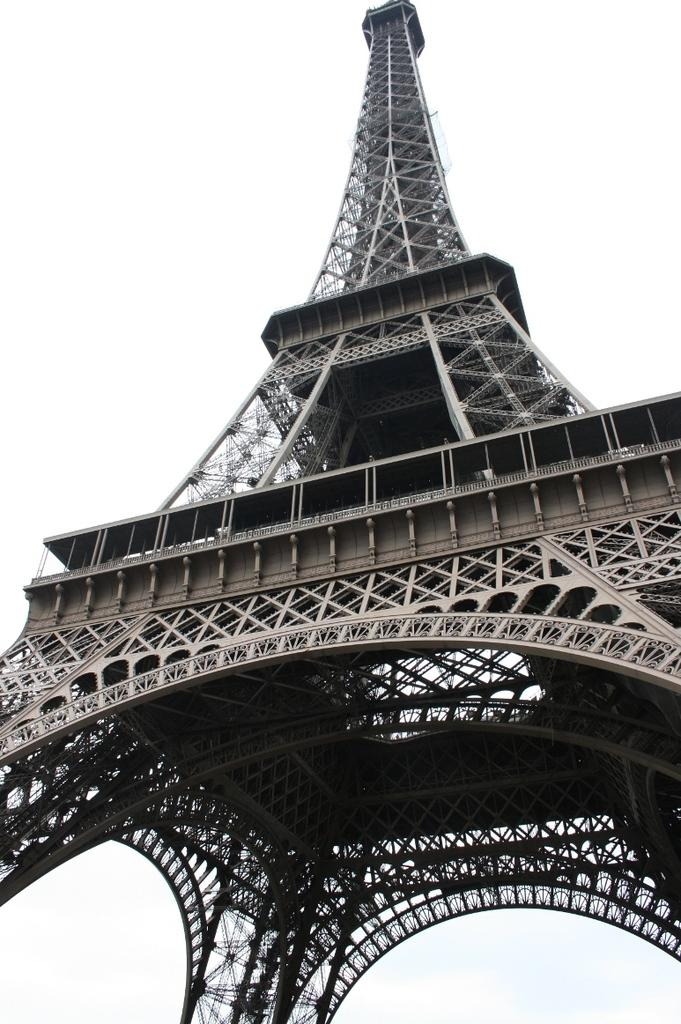What famous landmark is depicted in the image? There is a picture of the Eiffel Tower in the image. What type of science experiment is being conducted in the lunchroom in the image? There is no lunchroom or science experiment present in the image; it features a picture of the Eiffel Tower. What type of alley is visible in the image? There is no alley present in the image; it features a picture of the Eiffel Tower. 